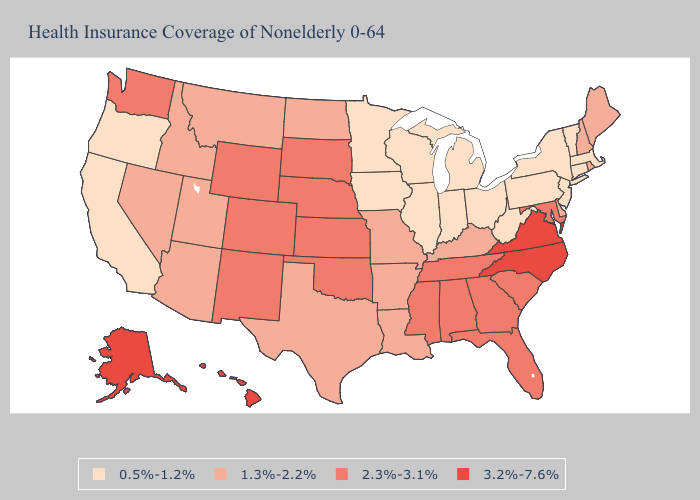Does Nebraska have a higher value than Oklahoma?
Give a very brief answer. No. Does West Virginia have the lowest value in the South?
Quick response, please. Yes. Name the states that have a value in the range 1.3%-2.2%?
Keep it brief. Arizona, Arkansas, Delaware, Idaho, Kentucky, Louisiana, Maine, Missouri, Montana, Nevada, New Hampshire, North Dakota, Rhode Island, Texas, Utah. Does Idaho have a lower value than Washington?
Give a very brief answer. Yes. Does Minnesota have the lowest value in the MidWest?
Give a very brief answer. Yes. What is the value of Colorado?
Concise answer only. 2.3%-3.1%. What is the lowest value in the South?
Answer briefly. 0.5%-1.2%. What is the value of Wyoming?
Quick response, please. 2.3%-3.1%. Does Illinois have the lowest value in the USA?
Answer briefly. Yes. What is the value of Washington?
Be succinct. 2.3%-3.1%. What is the value of North Carolina?
Answer briefly. 3.2%-7.6%. Does Kansas have the lowest value in the MidWest?
Short answer required. No. Does the first symbol in the legend represent the smallest category?
Keep it brief. Yes. Name the states that have a value in the range 0.5%-1.2%?
Write a very short answer. California, Connecticut, Illinois, Indiana, Iowa, Massachusetts, Michigan, Minnesota, New Jersey, New York, Ohio, Oregon, Pennsylvania, Vermont, West Virginia, Wisconsin. 